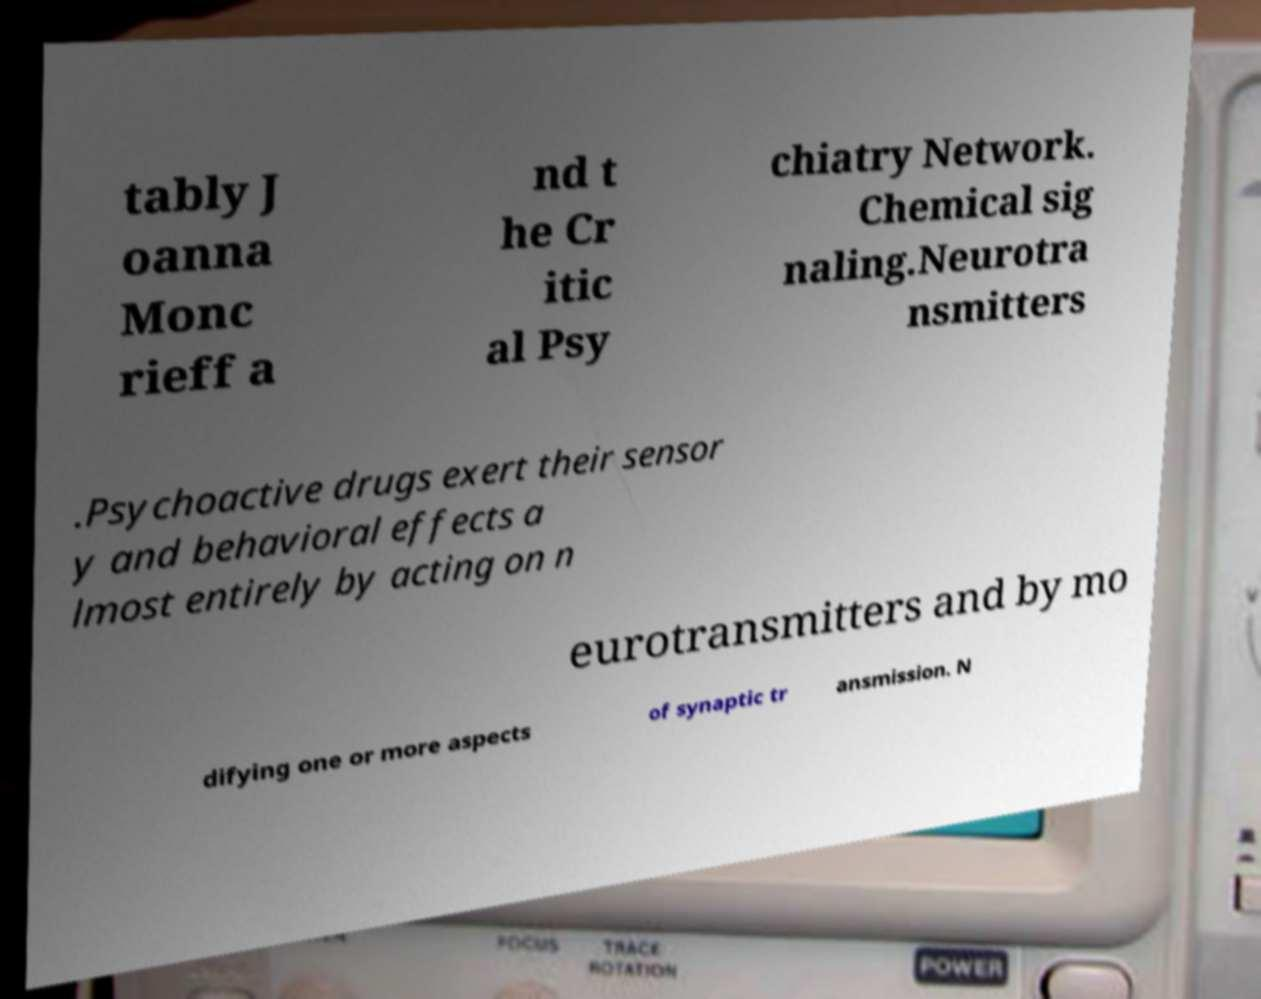What messages or text are displayed in this image? I need them in a readable, typed format. tably J oanna Monc rieff a nd t he Cr itic al Psy chiatry Network. Chemical sig naling.Neurotra nsmitters .Psychoactive drugs exert their sensor y and behavioral effects a lmost entirely by acting on n eurotransmitters and by mo difying one or more aspects of synaptic tr ansmission. N 